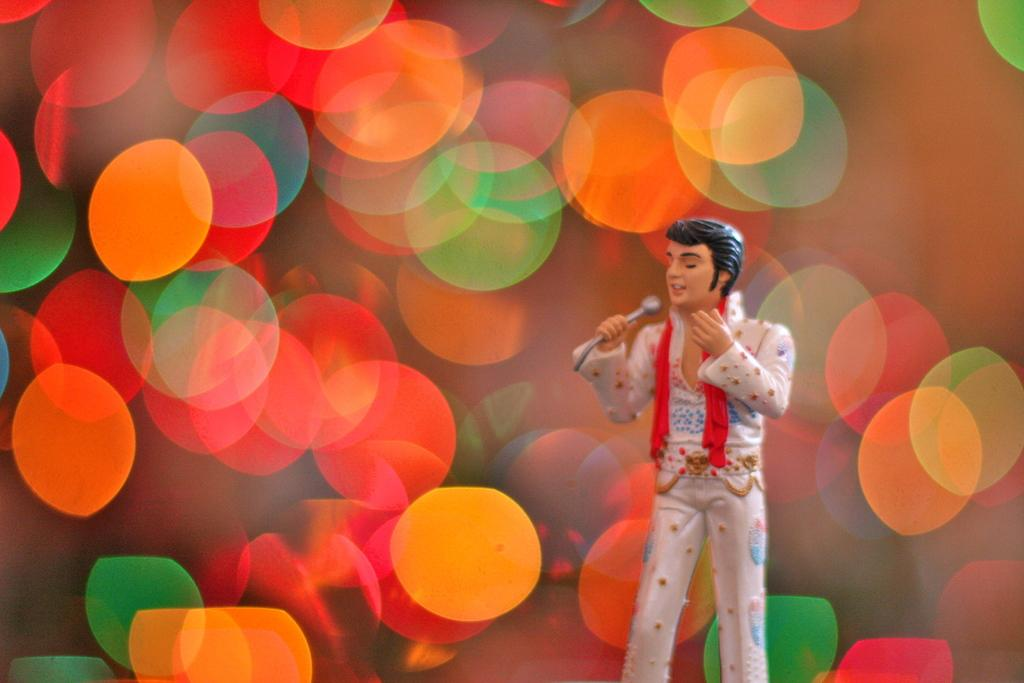What type of object is in the image? There is a toy of a person in the image. What is the toy person doing? The toy person is standing and holding a microphone (mike). What can be seen behind the toy person? There is a colorful background in the image. How does the toy person wash their hands in the image? There is no indication in the image that the toy person is washing their hands, as they are holding a microphone and standing. 